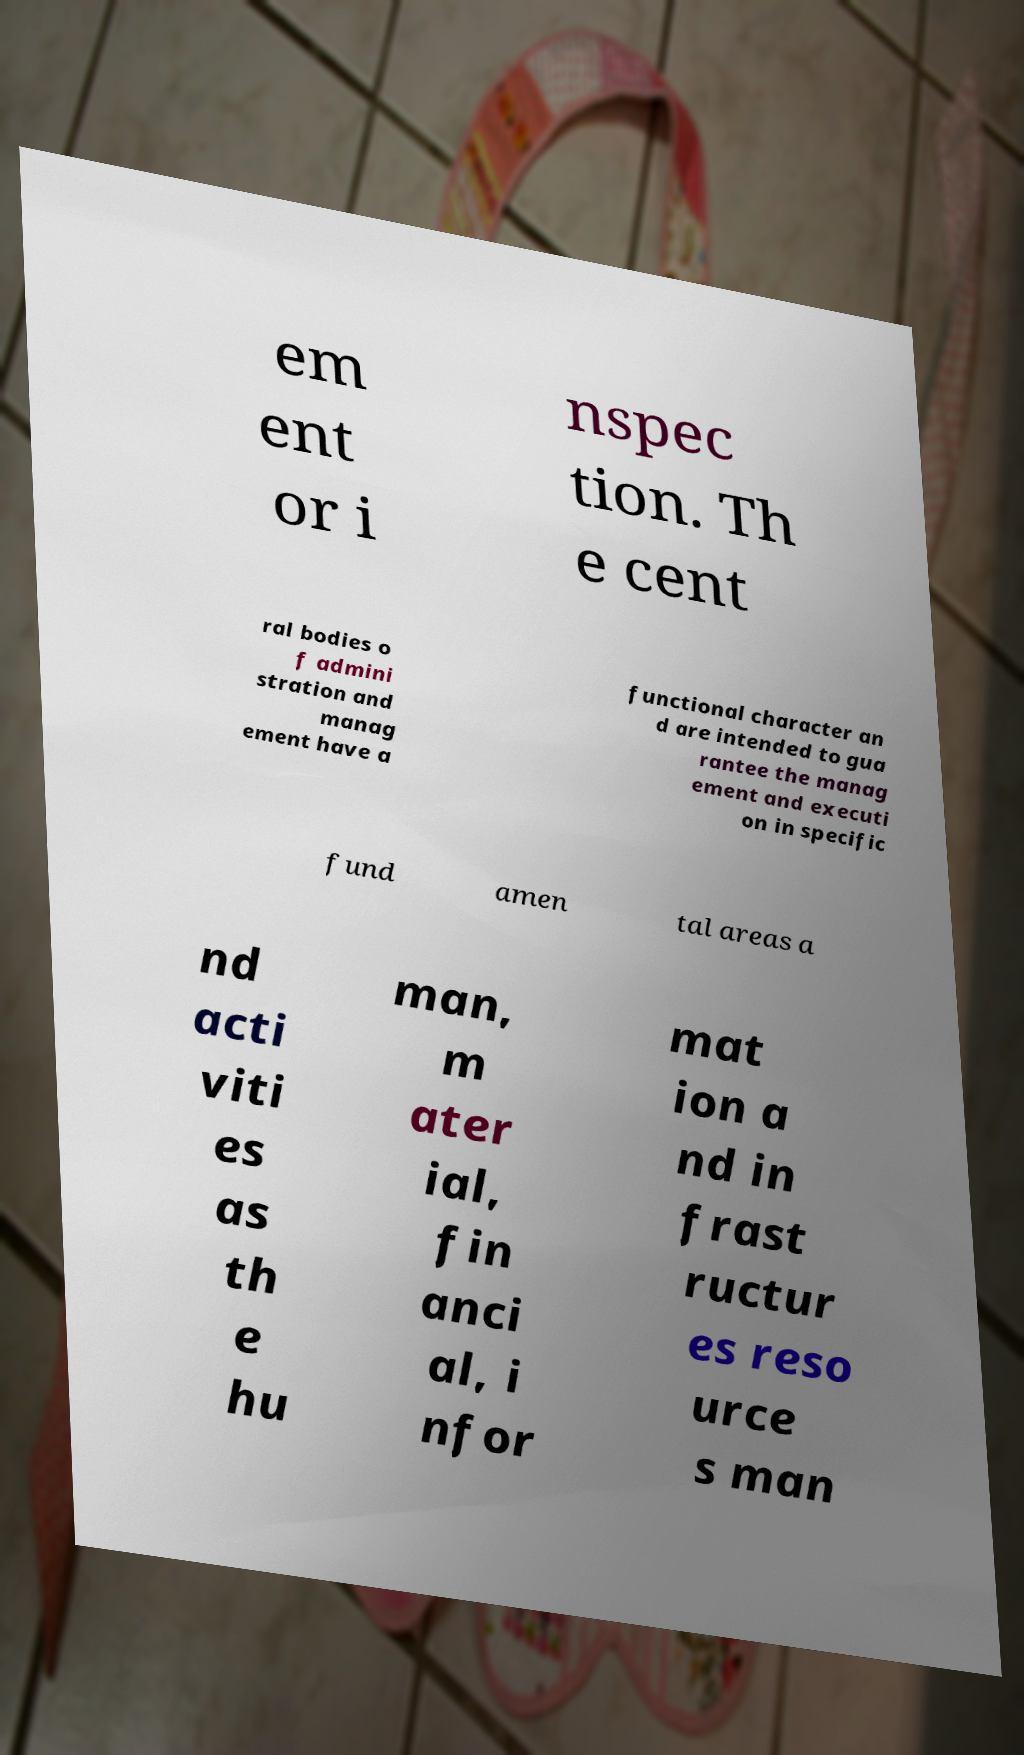There's text embedded in this image that I need extracted. Can you transcribe it verbatim? em ent or i nspec tion. Th e cent ral bodies o f admini stration and manag ement have a functional character an d are intended to gua rantee the manag ement and executi on in specific fund amen tal areas a nd acti viti es as th e hu man, m ater ial, fin anci al, i nfor mat ion a nd in frast ructur es reso urce s man 